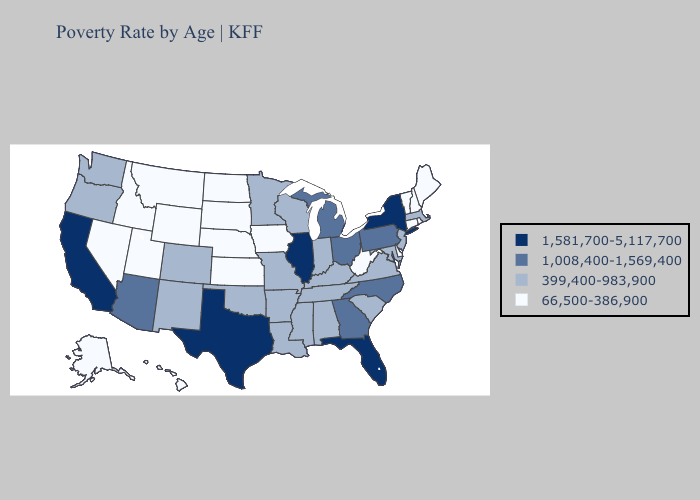Does Pennsylvania have a lower value than Illinois?
Answer briefly. Yes. What is the highest value in states that border Missouri?
Quick response, please. 1,581,700-5,117,700. What is the highest value in states that border Wyoming?
Keep it brief. 399,400-983,900. Does New Hampshire have the highest value in the USA?
Answer briefly. No. Does the first symbol in the legend represent the smallest category?
Concise answer only. No. Does the map have missing data?
Concise answer only. No. Among the states that border Georgia , does Florida have the lowest value?
Short answer required. No. What is the value of Oregon?
Write a very short answer. 399,400-983,900. Does Nevada have a higher value than North Carolina?
Short answer required. No. What is the highest value in the USA?
Write a very short answer. 1,581,700-5,117,700. What is the highest value in the USA?
Quick response, please. 1,581,700-5,117,700. Does Florida have a higher value than New York?
Keep it brief. No. Among the states that border California , which have the highest value?
Keep it brief. Arizona. What is the value of Maine?
Be succinct. 66,500-386,900. 